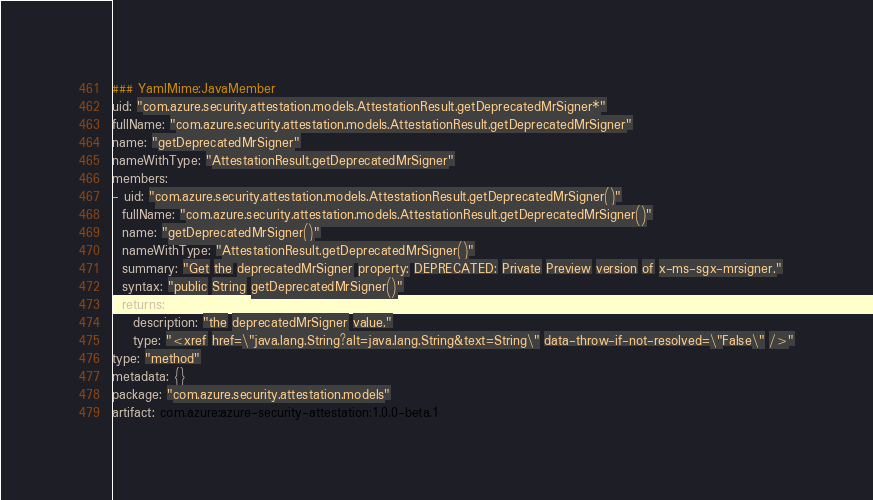Convert code to text. <code><loc_0><loc_0><loc_500><loc_500><_YAML_>### YamlMime:JavaMember
uid: "com.azure.security.attestation.models.AttestationResult.getDeprecatedMrSigner*"
fullName: "com.azure.security.attestation.models.AttestationResult.getDeprecatedMrSigner"
name: "getDeprecatedMrSigner"
nameWithType: "AttestationResult.getDeprecatedMrSigner"
members:
- uid: "com.azure.security.attestation.models.AttestationResult.getDeprecatedMrSigner()"
  fullName: "com.azure.security.attestation.models.AttestationResult.getDeprecatedMrSigner()"
  name: "getDeprecatedMrSigner()"
  nameWithType: "AttestationResult.getDeprecatedMrSigner()"
  summary: "Get the deprecatedMrSigner property: DEPRECATED: Private Preview version of x-ms-sgx-mrsigner."
  syntax: "public String getDeprecatedMrSigner()"
  returns:
    description: "the deprecatedMrSigner value."
    type: "<xref href=\"java.lang.String?alt=java.lang.String&text=String\" data-throw-if-not-resolved=\"False\" />"
type: "method"
metadata: {}
package: "com.azure.security.attestation.models"
artifact: com.azure:azure-security-attestation:1.0.0-beta.1
</code> 